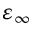Convert formula to latex. <formula><loc_0><loc_0><loc_500><loc_500>\varepsilon _ { \infty }</formula> 